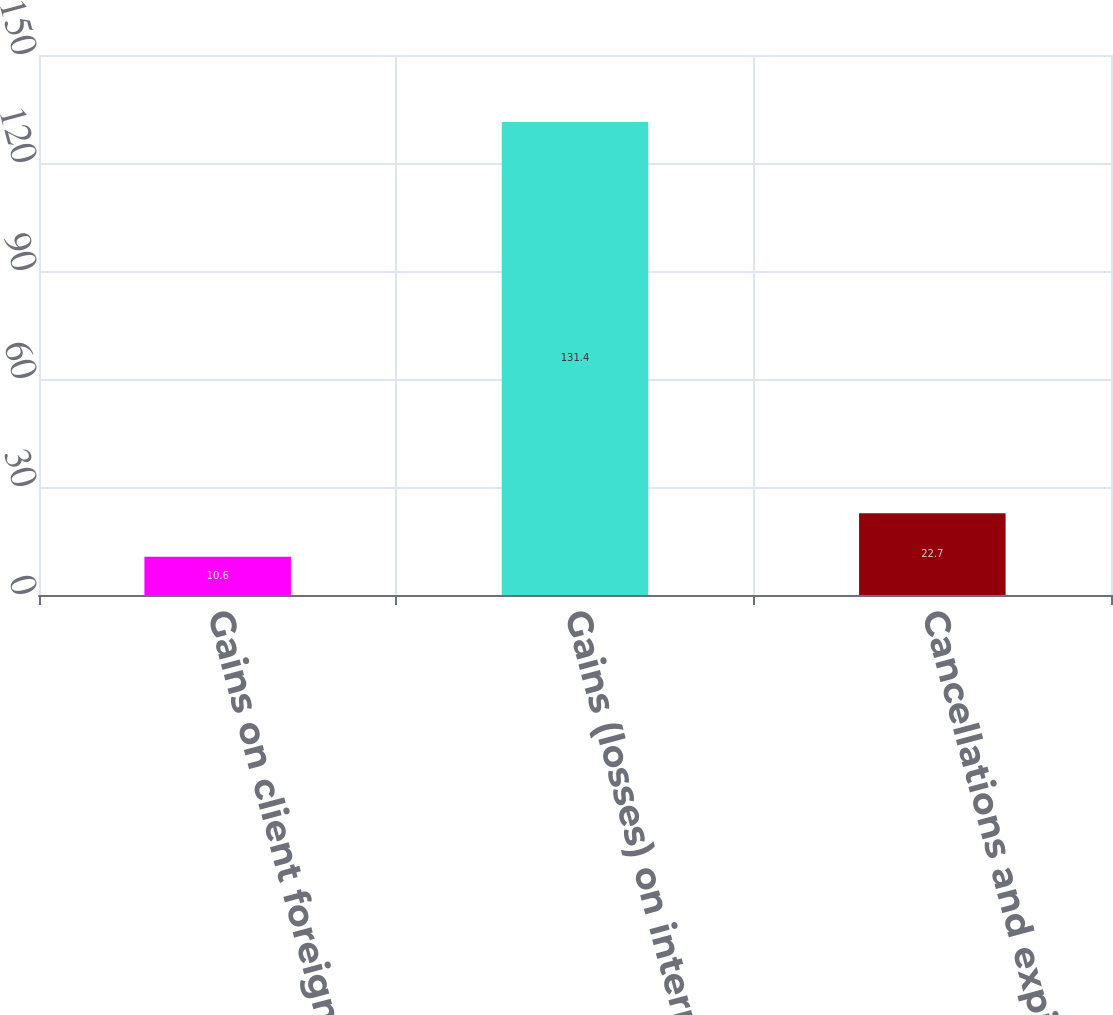Convert chart to OTSL. <chart><loc_0><loc_0><loc_500><loc_500><bar_chart><fcel>Gains on client foreign<fcel>Gains (losses) on internal<fcel>Cancellations and expirations<nl><fcel>10.6<fcel>131.4<fcel>22.7<nl></chart> 